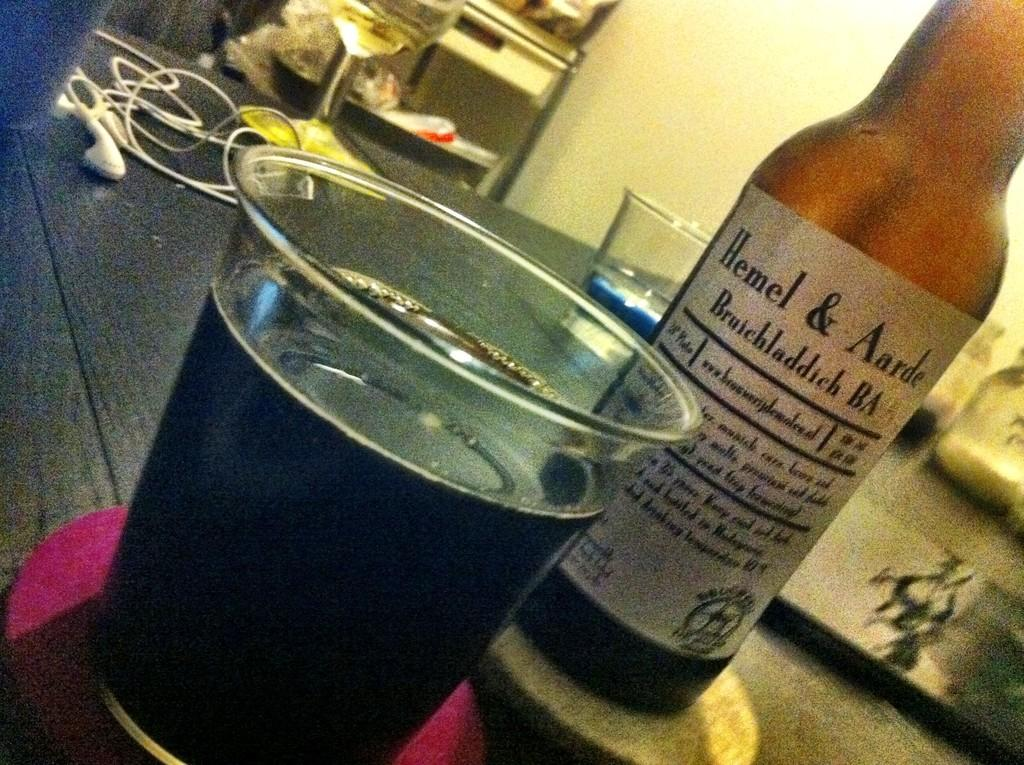<image>
Share a concise interpretation of the image provided. Bottle of Hemel & Aarde with a cup full beside it 